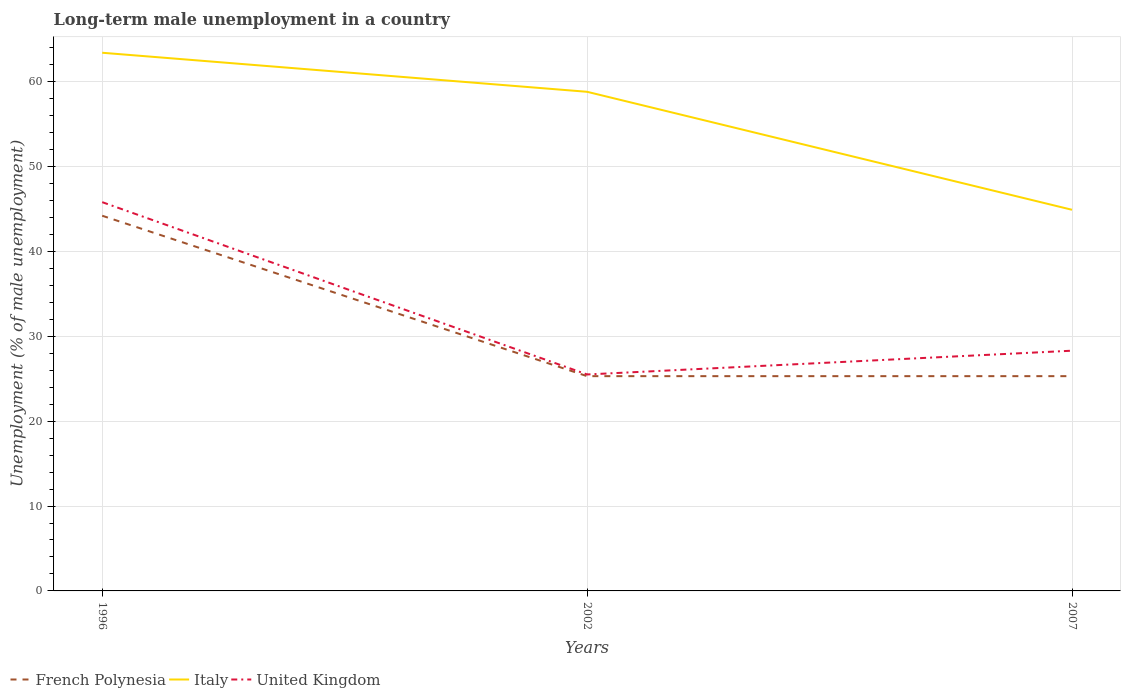Is the number of lines equal to the number of legend labels?
Give a very brief answer. Yes. Across all years, what is the maximum percentage of long-term unemployed male population in Italy?
Provide a succinct answer. 44.9. What is the difference between the highest and the second highest percentage of long-term unemployed male population in Italy?
Keep it short and to the point. 18.5. Does the graph contain any zero values?
Your answer should be compact. No. Does the graph contain grids?
Give a very brief answer. Yes. Where does the legend appear in the graph?
Your answer should be very brief. Bottom left. What is the title of the graph?
Provide a succinct answer. Long-term male unemployment in a country. What is the label or title of the Y-axis?
Offer a terse response. Unemployment (% of male unemployment). What is the Unemployment (% of male unemployment) in French Polynesia in 1996?
Make the answer very short. 44.2. What is the Unemployment (% of male unemployment) of Italy in 1996?
Your answer should be compact. 63.4. What is the Unemployment (% of male unemployment) of United Kingdom in 1996?
Your answer should be compact. 45.8. What is the Unemployment (% of male unemployment) in French Polynesia in 2002?
Offer a very short reply. 25.3. What is the Unemployment (% of male unemployment) of Italy in 2002?
Give a very brief answer. 58.8. What is the Unemployment (% of male unemployment) of French Polynesia in 2007?
Offer a terse response. 25.3. What is the Unemployment (% of male unemployment) in Italy in 2007?
Your answer should be compact. 44.9. What is the Unemployment (% of male unemployment) in United Kingdom in 2007?
Your answer should be very brief. 28.3. Across all years, what is the maximum Unemployment (% of male unemployment) in French Polynesia?
Make the answer very short. 44.2. Across all years, what is the maximum Unemployment (% of male unemployment) in Italy?
Make the answer very short. 63.4. Across all years, what is the maximum Unemployment (% of male unemployment) of United Kingdom?
Offer a terse response. 45.8. Across all years, what is the minimum Unemployment (% of male unemployment) of French Polynesia?
Keep it short and to the point. 25.3. Across all years, what is the minimum Unemployment (% of male unemployment) of Italy?
Keep it short and to the point. 44.9. What is the total Unemployment (% of male unemployment) of French Polynesia in the graph?
Keep it short and to the point. 94.8. What is the total Unemployment (% of male unemployment) in Italy in the graph?
Make the answer very short. 167.1. What is the total Unemployment (% of male unemployment) in United Kingdom in the graph?
Give a very brief answer. 99.6. What is the difference between the Unemployment (% of male unemployment) of Italy in 1996 and that in 2002?
Your response must be concise. 4.6. What is the difference between the Unemployment (% of male unemployment) in United Kingdom in 1996 and that in 2002?
Ensure brevity in your answer.  20.3. What is the difference between the Unemployment (% of male unemployment) in French Polynesia in 1996 and that in 2007?
Make the answer very short. 18.9. What is the difference between the Unemployment (% of male unemployment) of French Polynesia in 2002 and that in 2007?
Make the answer very short. 0. What is the difference between the Unemployment (% of male unemployment) of United Kingdom in 2002 and that in 2007?
Provide a short and direct response. -2.8. What is the difference between the Unemployment (% of male unemployment) in French Polynesia in 1996 and the Unemployment (% of male unemployment) in Italy in 2002?
Offer a terse response. -14.6. What is the difference between the Unemployment (% of male unemployment) of Italy in 1996 and the Unemployment (% of male unemployment) of United Kingdom in 2002?
Your answer should be compact. 37.9. What is the difference between the Unemployment (% of male unemployment) of Italy in 1996 and the Unemployment (% of male unemployment) of United Kingdom in 2007?
Offer a very short reply. 35.1. What is the difference between the Unemployment (% of male unemployment) of French Polynesia in 2002 and the Unemployment (% of male unemployment) of Italy in 2007?
Your answer should be compact. -19.6. What is the difference between the Unemployment (% of male unemployment) in French Polynesia in 2002 and the Unemployment (% of male unemployment) in United Kingdom in 2007?
Give a very brief answer. -3. What is the difference between the Unemployment (% of male unemployment) in Italy in 2002 and the Unemployment (% of male unemployment) in United Kingdom in 2007?
Your answer should be very brief. 30.5. What is the average Unemployment (% of male unemployment) of French Polynesia per year?
Your response must be concise. 31.6. What is the average Unemployment (% of male unemployment) of Italy per year?
Ensure brevity in your answer.  55.7. What is the average Unemployment (% of male unemployment) in United Kingdom per year?
Your answer should be compact. 33.2. In the year 1996, what is the difference between the Unemployment (% of male unemployment) of French Polynesia and Unemployment (% of male unemployment) of Italy?
Provide a succinct answer. -19.2. In the year 1996, what is the difference between the Unemployment (% of male unemployment) in French Polynesia and Unemployment (% of male unemployment) in United Kingdom?
Your response must be concise. -1.6. In the year 2002, what is the difference between the Unemployment (% of male unemployment) of French Polynesia and Unemployment (% of male unemployment) of Italy?
Offer a terse response. -33.5. In the year 2002, what is the difference between the Unemployment (% of male unemployment) of Italy and Unemployment (% of male unemployment) of United Kingdom?
Ensure brevity in your answer.  33.3. In the year 2007, what is the difference between the Unemployment (% of male unemployment) of French Polynesia and Unemployment (% of male unemployment) of Italy?
Offer a very short reply. -19.6. In the year 2007, what is the difference between the Unemployment (% of male unemployment) of Italy and Unemployment (% of male unemployment) of United Kingdom?
Your answer should be compact. 16.6. What is the ratio of the Unemployment (% of male unemployment) of French Polynesia in 1996 to that in 2002?
Ensure brevity in your answer.  1.75. What is the ratio of the Unemployment (% of male unemployment) in Italy in 1996 to that in 2002?
Your answer should be compact. 1.08. What is the ratio of the Unemployment (% of male unemployment) in United Kingdom in 1996 to that in 2002?
Offer a terse response. 1.8. What is the ratio of the Unemployment (% of male unemployment) in French Polynesia in 1996 to that in 2007?
Your answer should be very brief. 1.75. What is the ratio of the Unemployment (% of male unemployment) in Italy in 1996 to that in 2007?
Provide a succinct answer. 1.41. What is the ratio of the Unemployment (% of male unemployment) of United Kingdom in 1996 to that in 2007?
Keep it short and to the point. 1.62. What is the ratio of the Unemployment (% of male unemployment) of French Polynesia in 2002 to that in 2007?
Offer a very short reply. 1. What is the ratio of the Unemployment (% of male unemployment) of Italy in 2002 to that in 2007?
Offer a terse response. 1.31. What is the ratio of the Unemployment (% of male unemployment) of United Kingdom in 2002 to that in 2007?
Your response must be concise. 0.9. What is the difference between the highest and the second highest Unemployment (% of male unemployment) of Italy?
Offer a very short reply. 4.6. What is the difference between the highest and the lowest Unemployment (% of male unemployment) in United Kingdom?
Ensure brevity in your answer.  20.3. 